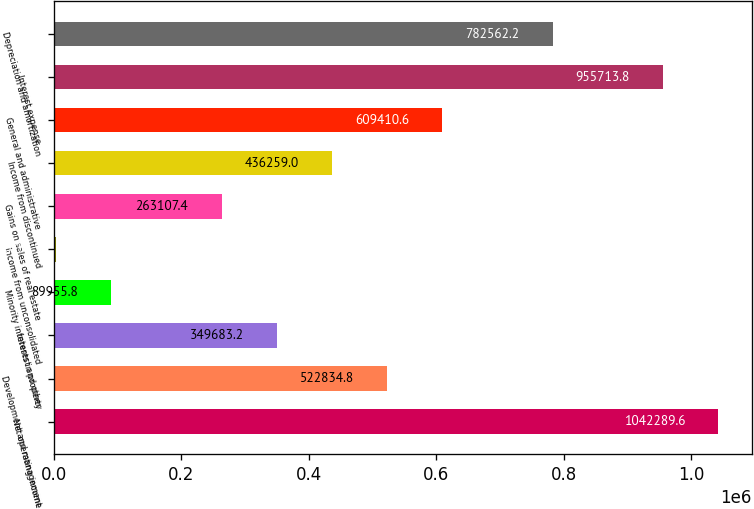Convert chart to OTSL. <chart><loc_0><loc_0><loc_500><loc_500><bar_chart><fcel>Net operating income<fcel>Development and management<fcel>Interest and other<fcel>Minority interests in property<fcel>Income from unconsolidated<fcel>Gains on sales of real estate<fcel>Income from discontinued<fcel>General and administrative<fcel>Interest expense<fcel>Depreciation and amortization<nl><fcel>1.04229e+06<fcel>522835<fcel>349683<fcel>89955.8<fcel>3380<fcel>263107<fcel>436259<fcel>609411<fcel>955714<fcel>782562<nl></chart> 